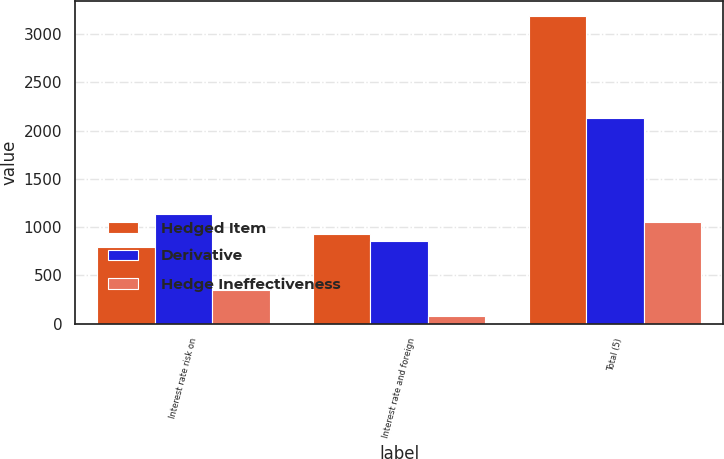<chart> <loc_0><loc_0><loc_500><loc_500><stacked_bar_chart><ecel><fcel>Interest rate risk on<fcel>Interest rate and foreign<fcel>Total (5)<nl><fcel>Hedged Item<fcel>791<fcel>932<fcel>3186<nl><fcel>Derivative<fcel>1141<fcel>858<fcel>2134<nl><fcel>Hedge Ineffectiveness<fcel>350<fcel>74<fcel>1052<nl></chart> 